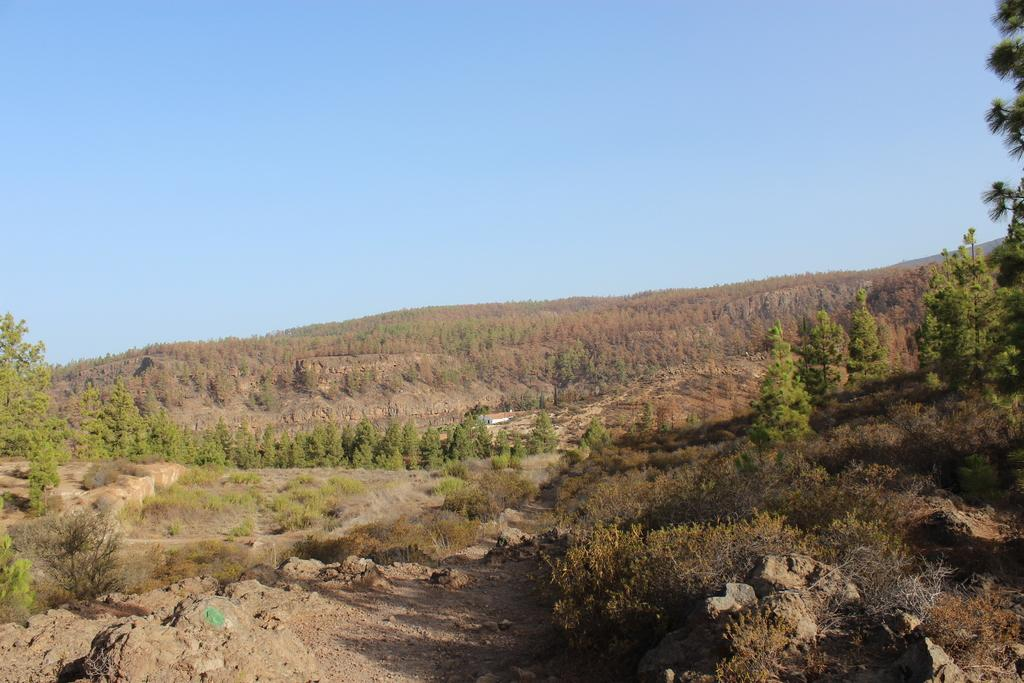What is the main feature of the image? There is a mountain in the image. What can be found on the mountain? The mountain has trees and plants on it, as well as rock stones. What is visible in the background of the image? The sky is visible in the image. What type of dolls can be seen playing on the mountain in the image? There are no dolls present in the image; it features a mountain with trees, plants, and rock stones. 